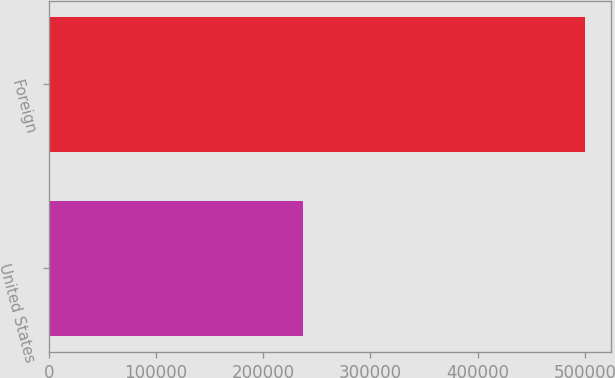<chart> <loc_0><loc_0><loc_500><loc_500><bar_chart><fcel>United States<fcel>Foreign<nl><fcel>236932<fcel>499757<nl></chart> 